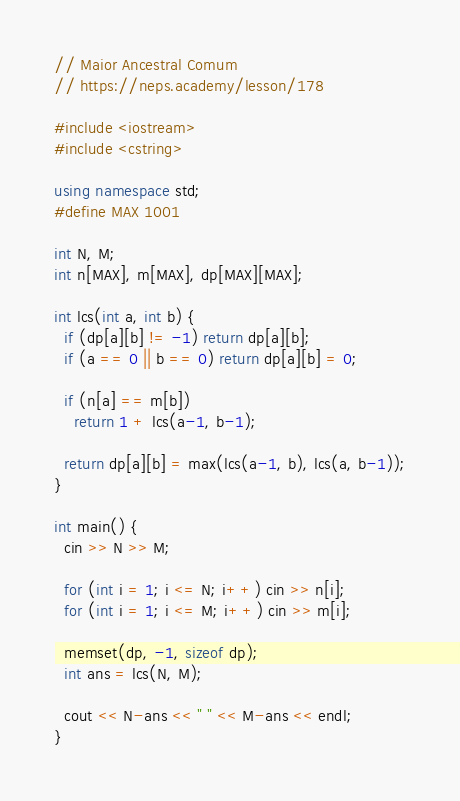Convert code to text. <code><loc_0><loc_0><loc_500><loc_500><_C++_>// Maior Ancestral Comum
// https://neps.academy/lesson/178

#include <iostream>
#include <cstring>

using namespace std;
#define MAX 1001

int N, M;
int n[MAX], m[MAX], dp[MAX][MAX];

int lcs(int a, int b) {
  if (dp[a][b] != -1) return dp[a][b];
  if (a == 0 || b == 0) return dp[a][b] = 0;

  if (n[a] == m[b])
    return 1 + lcs(a-1, b-1);

  return dp[a][b] = max(lcs(a-1, b), lcs(a, b-1));
}

int main() {
  cin >> N >> M;
  
  for (int i = 1; i <= N; i++) cin >> n[i];
  for (int i = 1; i <= M; i++) cin >> m[i];

  memset(dp, -1, sizeof dp);
  int ans = lcs(N, M);

  cout << N-ans << " " << M-ans << endl;
}
</code> 